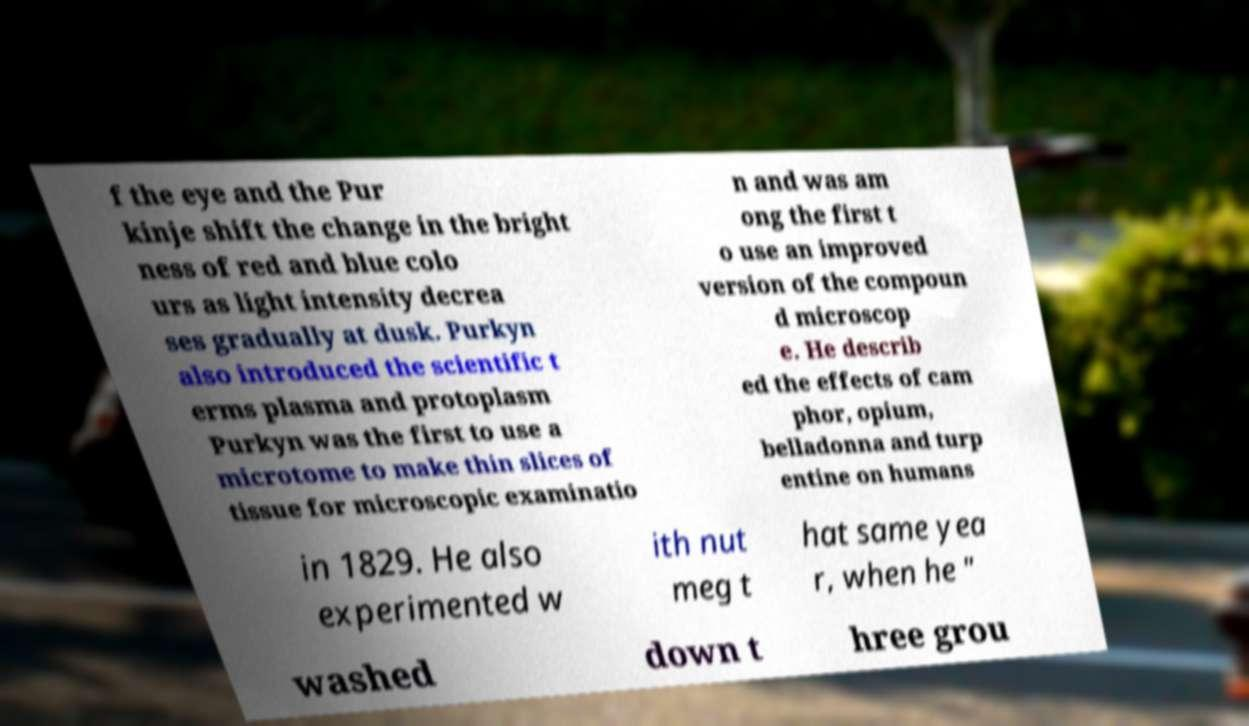Can you read and provide the text displayed in the image?This photo seems to have some interesting text. Can you extract and type it out for me? f the eye and the Pur kinje shift the change in the bright ness of red and blue colo urs as light intensity decrea ses gradually at dusk. Purkyn also introduced the scientific t erms plasma and protoplasm Purkyn was the first to use a microtome to make thin slices of tissue for microscopic examinatio n and was am ong the first t o use an improved version of the compoun d microscop e. He describ ed the effects of cam phor, opium, belladonna and turp entine on humans in 1829. He also experimented w ith nut meg t hat same yea r, when he " washed down t hree grou 